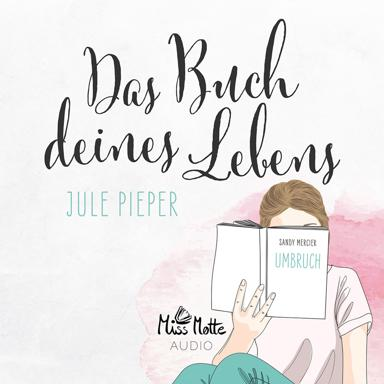Are any names mentioned in the image? Yes, the names 'Jule Pieper' and 'Sandy Mercier' are prominently displayed on the book cover in the image. Additionally, the terms 'IBRUCH' and 'Miss Motte AUDIO' are also visible, suggesting a relation to published audio content. 